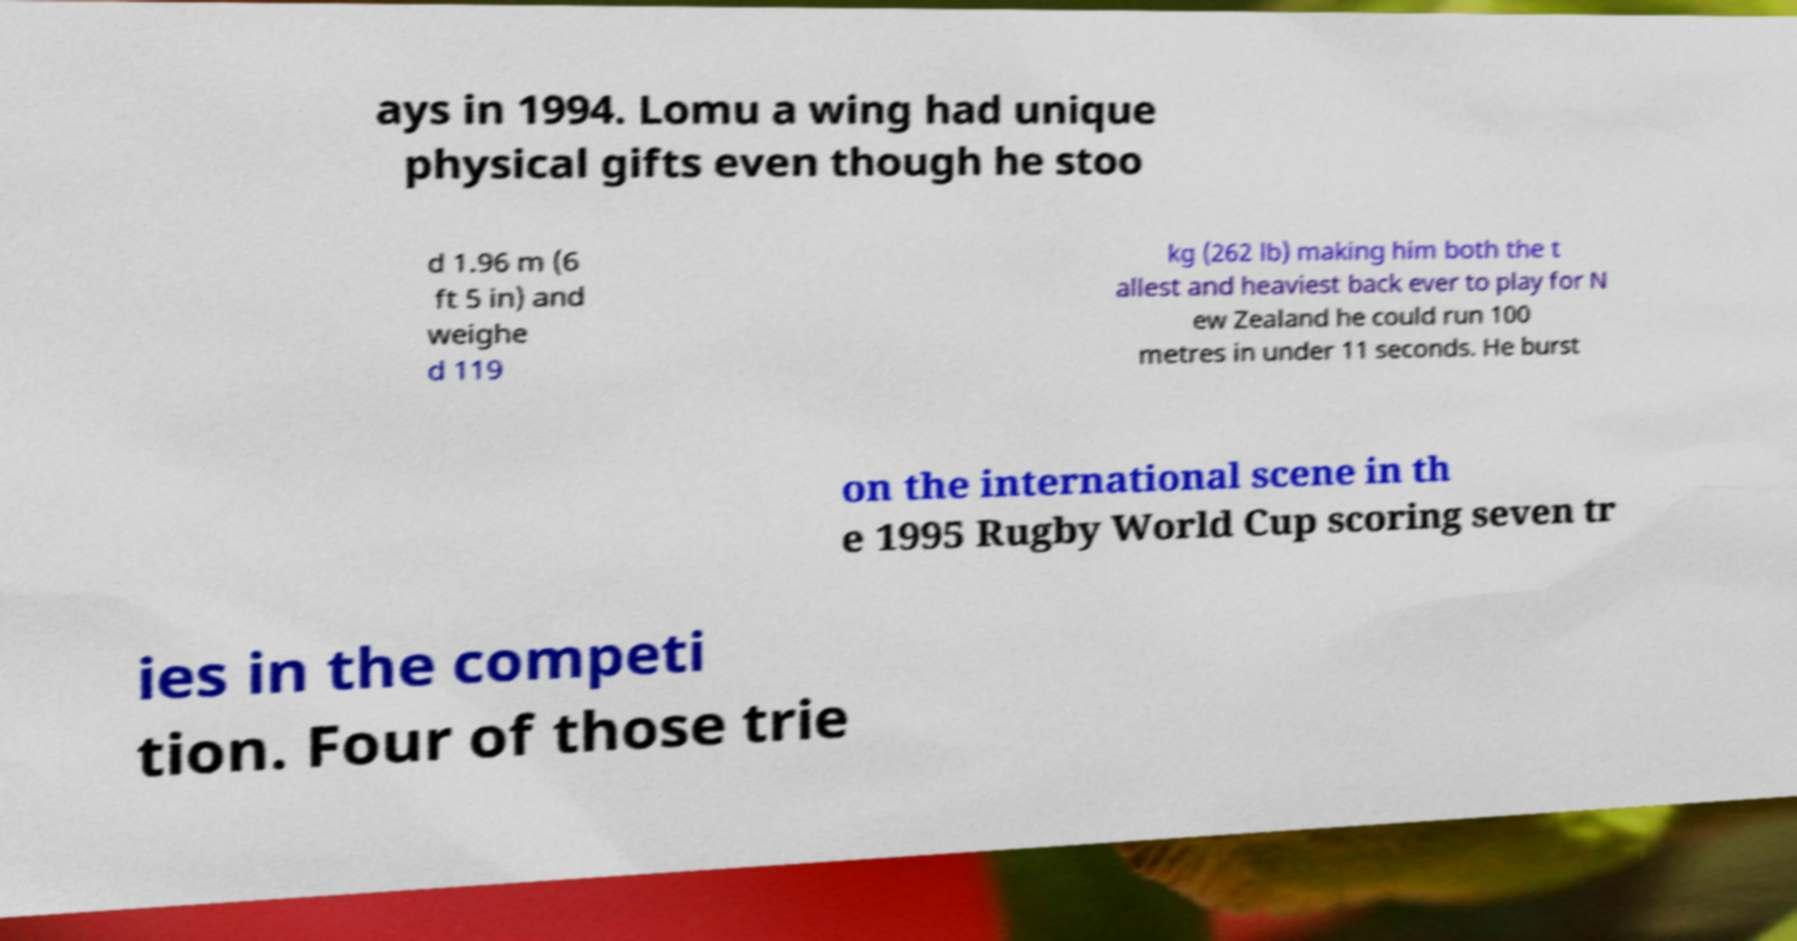Could you extract and type out the text from this image? ays in 1994. Lomu a wing had unique physical gifts even though he stoo d 1.96 m (6 ft 5 in) and weighe d 119 kg (262 lb) making him both the t allest and heaviest back ever to play for N ew Zealand he could run 100 metres in under 11 seconds. He burst on the international scene in th e 1995 Rugby World Cup scoring seven tr ies in the competi tion. Four of those trie 